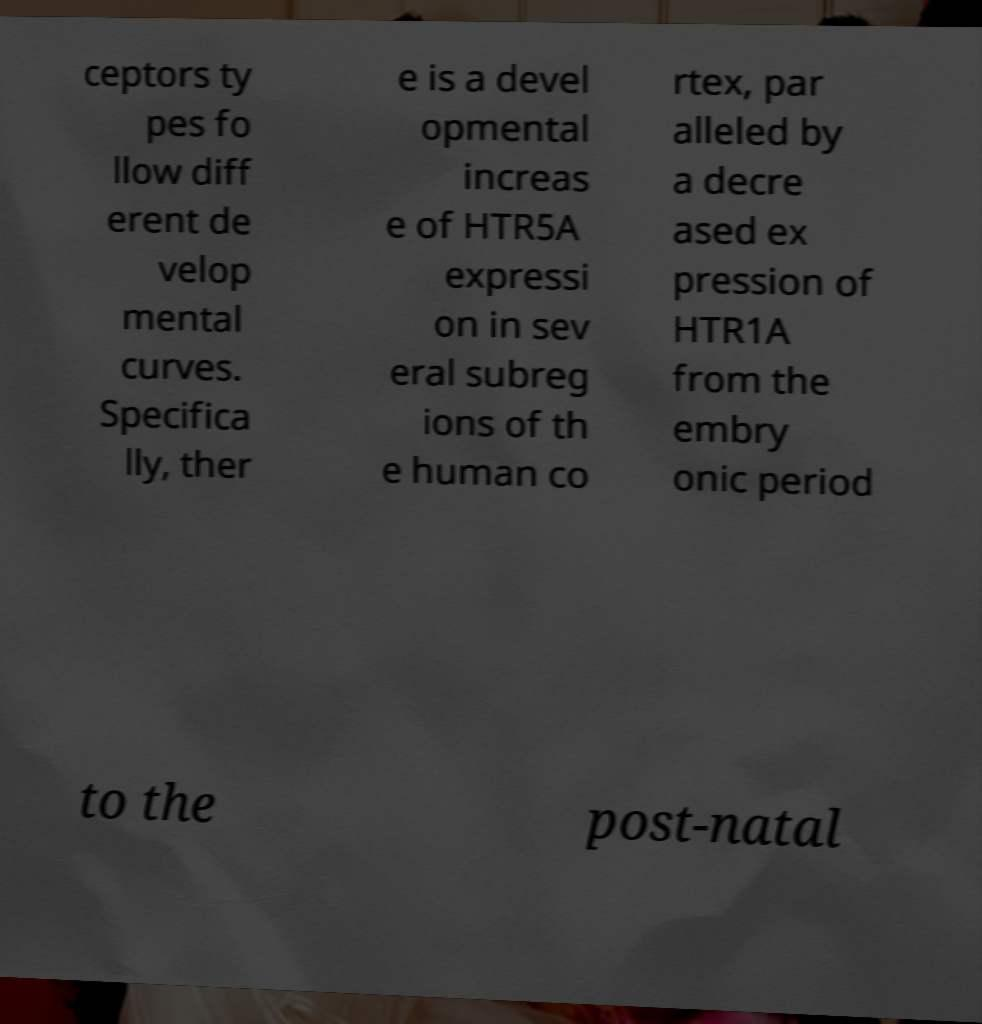Could you extract and type out the text from this image? ceptors ty pes fo llow diff erent de velop mental curves. Specifica lly, ther e is a devel opmental increas e of HTR5A expressi on in sev eral subreg ions of th e human co rtex, par alleled by a decre ased ex pression of HTR1A from the embry onic period to the post-natal 